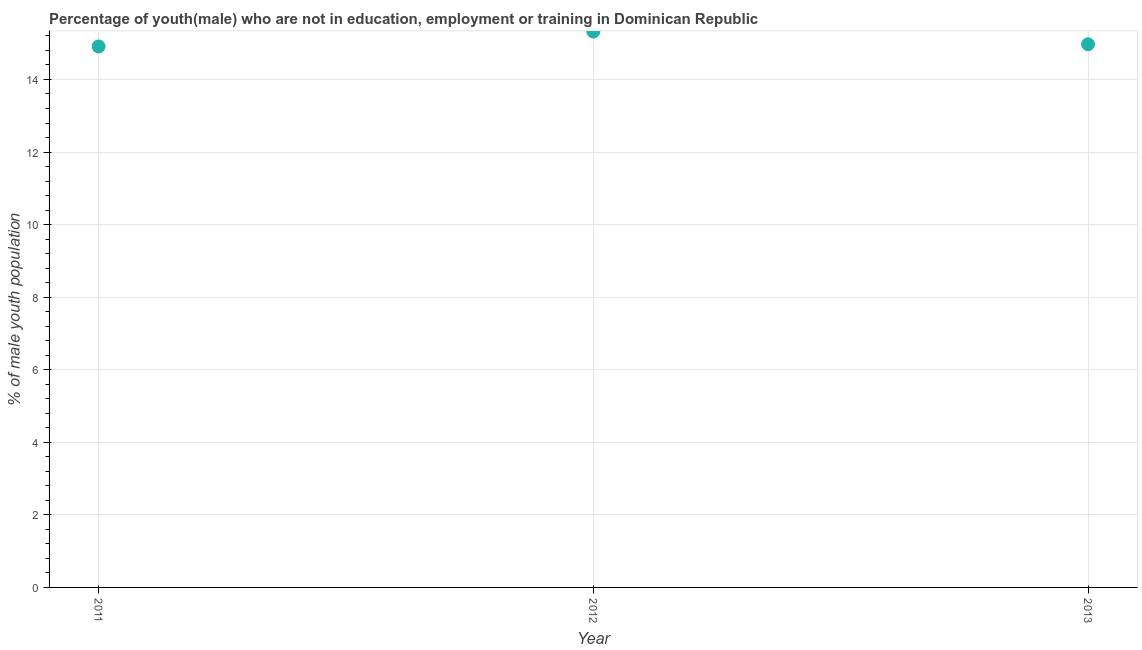What is the unemployed male youth population in 2012?
Ensure brevity in your answer.  15.32. Across all years, what is the maximum unemployed male youth population?
Provide a short and direct response. 15.32. Across all years, what is the minimum unemployed male youth population?
Offer a very short reply. 14.91. In which year was the unemployed male youth population minimum?
Ensure brevity in your answer.  2011. What is the sum of the unemployed male youth population?
Your response must be concise. 45.2. What is the difference between the unemployed male youth population in 2011 and 2013?
Your response must be concise. -0.06. What is the average unemployed male youth population per year?
Keep it short and to the point. 15.07. What is the median unemployed male youth population?
Provide a succinct answer. 14.97. What is the ratio of the unemployed male youth population in 2011 to that in 2012?
Provide a succinct answer. 0.97. Is the difference between the unemployed male youth population in 2011 and 2013 greater than the difference between any two years?
Your answer should be compact. No. What is the difference between the highest and the second highest unemployed male youth population?
Provide a succinct answer. 0.35. What is the difference between the highest and the lowest unemployed male youth population?
Ensure brevity in your answer.  0.41. Does the unemployed male youth population monotonically increase over the years?
Provide a short and direct response. No. How many dotlines are there?
Make the answer very short. 1. Are the values on the major ticks of Y-axis written in scientific E-notation?
Make the answer very short. No. Does the graph contain grids?
Offer a terse response. Yes. What is the title of the graph?
Your response must be concise. Percentage of youth(male) who are not in education, employment or training in Dominican Republic. What is the label or title of the X-axis?
Give a very brief answer. Year. What is the label or title of the Y-axis?
Keep it short and to the point. % of male youth population. What is the % of male youth population in 2011?
Provide a succinct answer. 14.91. What is the % of male youth population in 2012?
Your answer should be compact. 15.32. What is the % of male youth population in 2013?
Offer a terse response. 14.97. What is the difference between the % of male youth population in 2011 and 2012?
Offer a terse response. -0.41. What is the difference between the % of male youth population in 2011 and 2013?
Offer a very short reply. -0.06. What is the difference between the % of male youth population in 2012 and 2013?
Give a very brief answer. 0.35. What is the ratio of the % of male youth population in 2011 to that in 2013?
Offer a terse response. 1. What is the ratio of the % of male youth population in 2012 to that in 2013?
Offer a terse response. 1.02. 